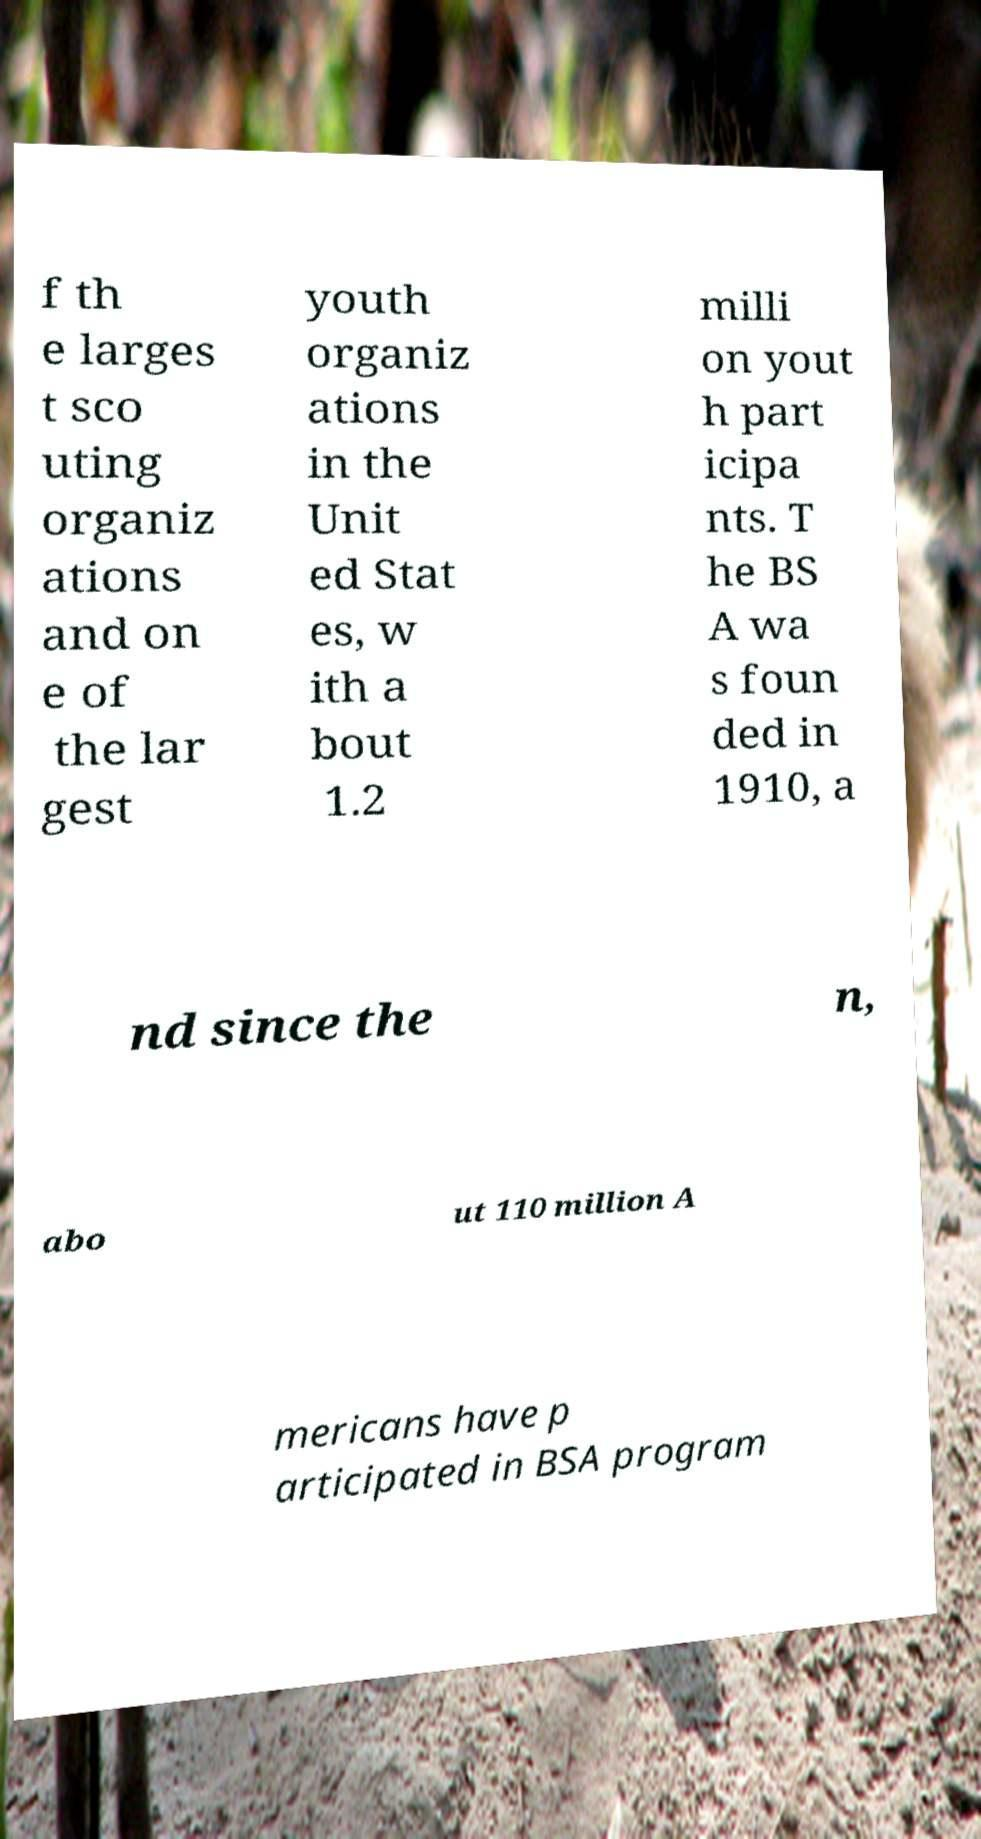I need the written content from this picture converted into text. Can you do that? f th e larges t sco uting organiz ations and on e of the lar gest youth organiz ations in the Unit ed Stat es, w ith a bout 1.2 milli on yout h part icipa nts. T he BS A wa s foun ded in 1910, a nd since the n, abo ut 110 million A mericans have p articipated in BSA program 